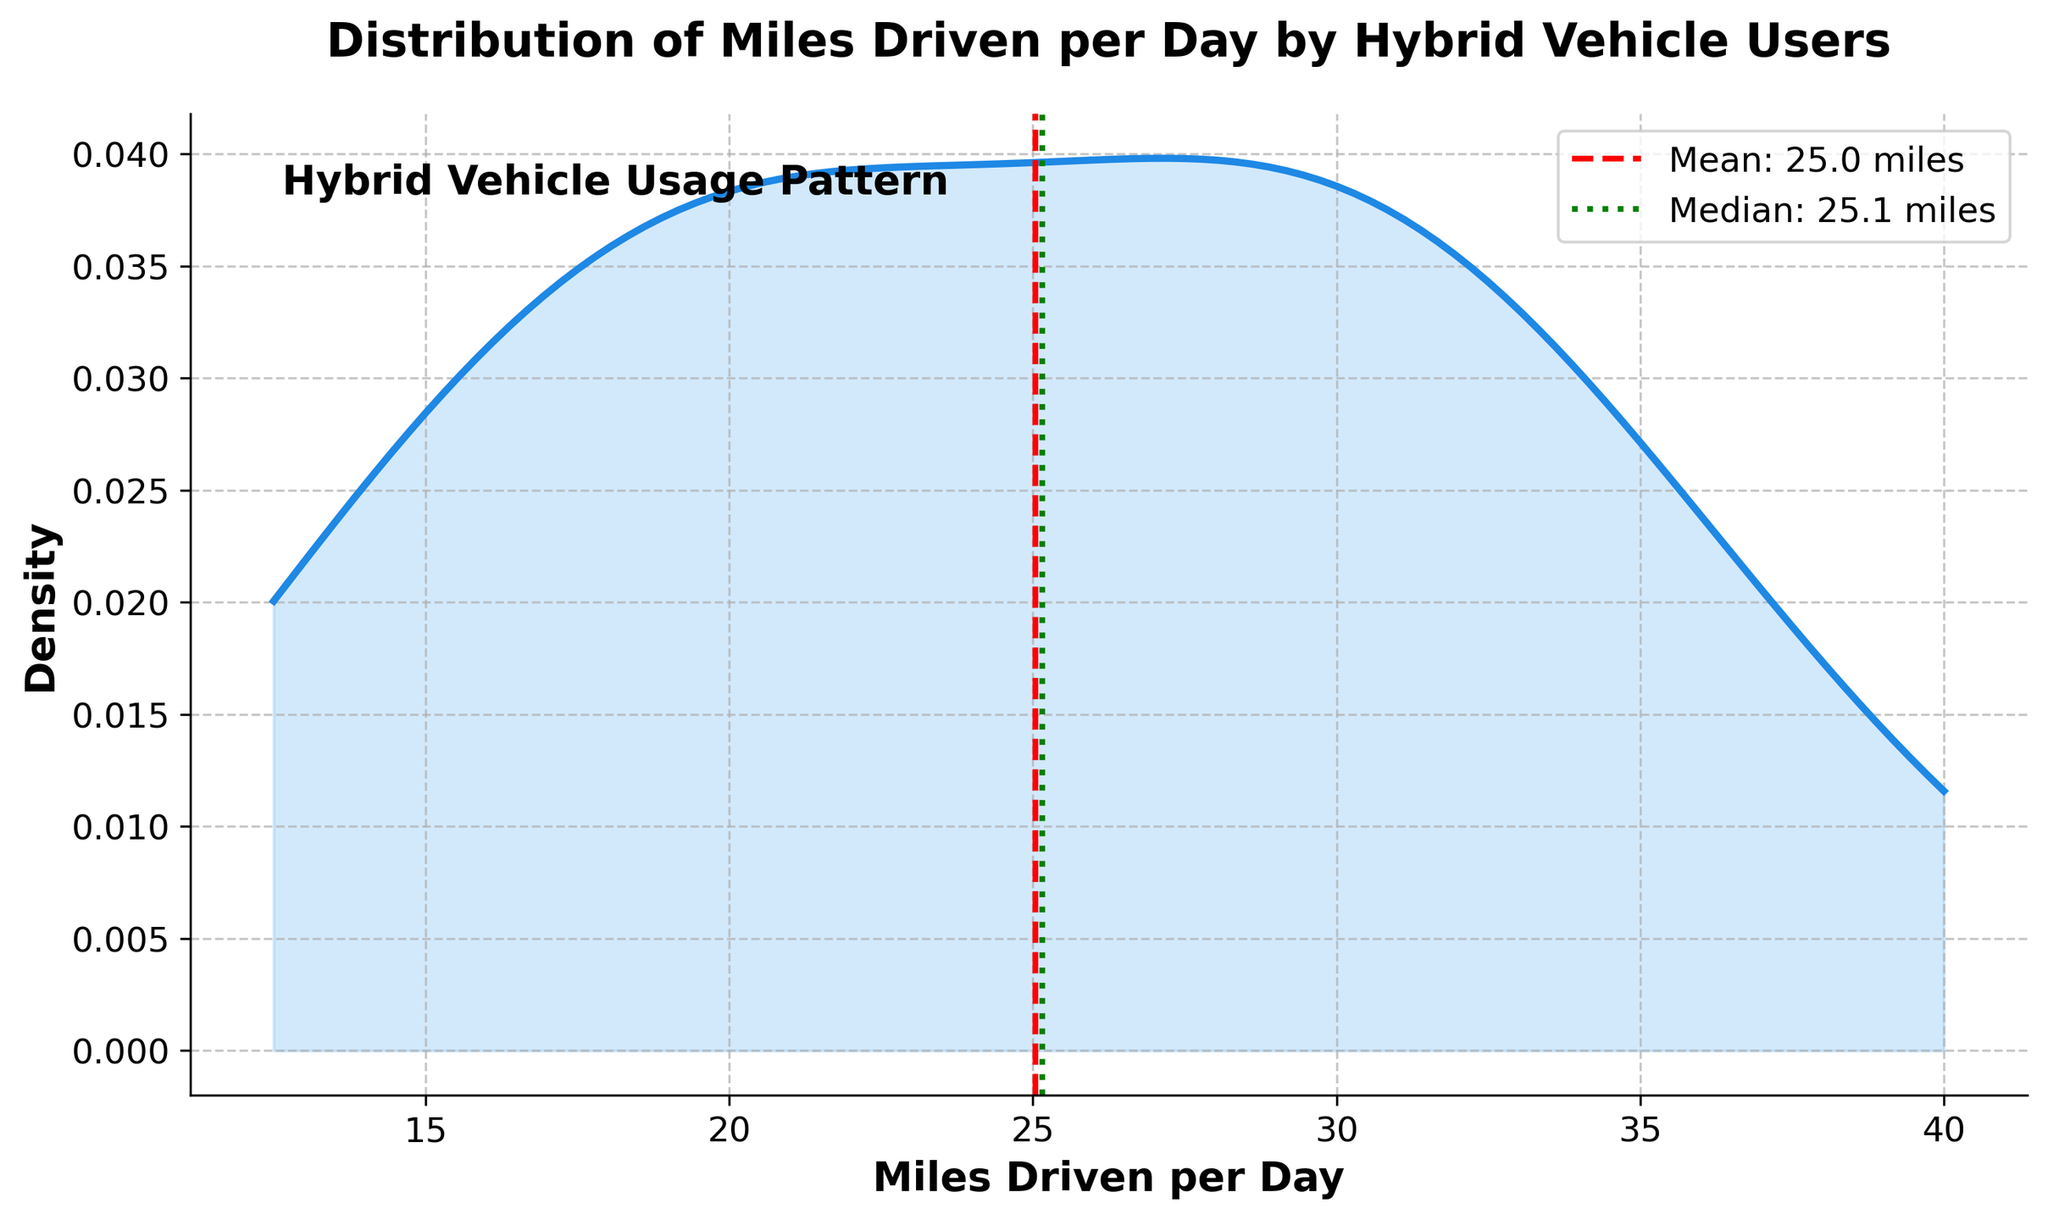What is the title of the plot? The title is given in a larger, bold font at the top of the plot. It helps to understand what data the plot represents.
Answer: Distribution of Miles Driven per Day by Hybrid Vehicle Users What is the label for the x-axis? The label for the x-axis is shown below the horizontal axis in a bold font. It's meant to describe what the x-axis represents in the plot.
Answer: Miles Driven per Day What color is used for the density line? The color of the density line can be visually observed. It helps in distinguishing the main density curve from the background and other elements.
Answer: Blue What two statistics are indicated by vertical lines on the plot? The plot includes two vertical lines, each of which is labeled. These lines help in identifying the mean and median values of miles driven.
Answer: Mean and Median What is the mean value of miles driven per day? The mean value is indicated by a red dashed vertical line, and it is labeled on the plot.
Answer: 24.4 miles What is the median value of miles driven per day? The median value is indicated by a green dotted vertical line, and it is labeled on the plot.
Answer: 24.5 miles How is the density plot shaded to indicate density areas? The density plot employs a fill between the density line and the horizontal axis to indicate areas of density. This shading helps to visualize the distribution more clearly.
Answer: Light blue What range of miles driven per day has the highest density according to the plot? The highest point on the density curve indicates the range with the highest density. This shows where the most frequent data points are clustered.
Answer: 20 to 30 miles How do the mean and median values compare in the plot? By observing the labeled vertical lines for both mean and median, one can compare their positions relative to each other. The position of these lines indicates their comparison.
Answer: They are very close to each other Is there a skewness in the distribution of miles driven per day? Skewness can be inferred from the shape of the density curve. If one tail is longer or the values are more spread out to one side, it shows skewness.
Answer: Slightly right-skewed 